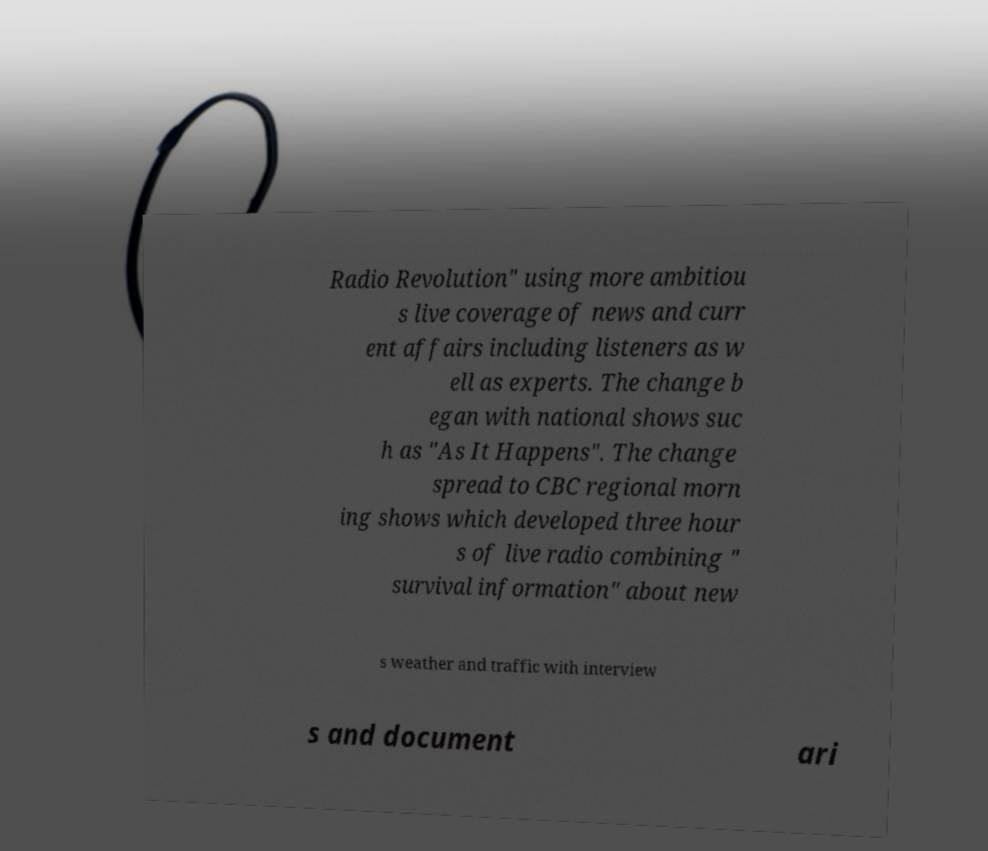There's text embedded in this image that I need extracted. Can you transcribe it verbatim? Radio Revolution" using more ambitiou s live coverage of news and curr ent affairs including listeners as w ell as experts. The change b egan with national shows suc h as "As It Happens". The change spread to CBC regional morn ing shows which developed three hour s of live radio combining " survival information" about new s weather and traffic with interview s and document ari 